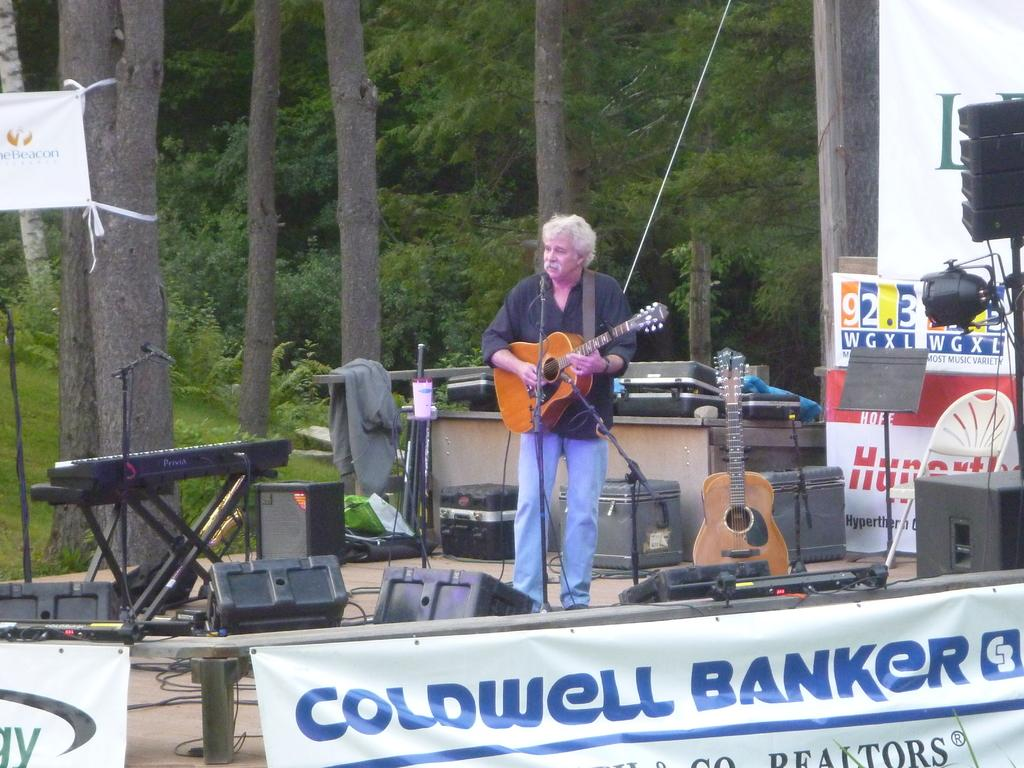What is the man in the image doing? The man is playing a guitar in the image. What can be seen in the background of the image? There is a banner, a speaker, a light, a tree, a jacket, another guitar, and a piano in the background. How many guitars are visible in the image? There are two guitars visible in the image. What type of park is visible in the image? There is no park present in the image. How does the man wish to use the guitar in the image? The image does not provide information about the man's intentions or wishes regarding the guitar. 